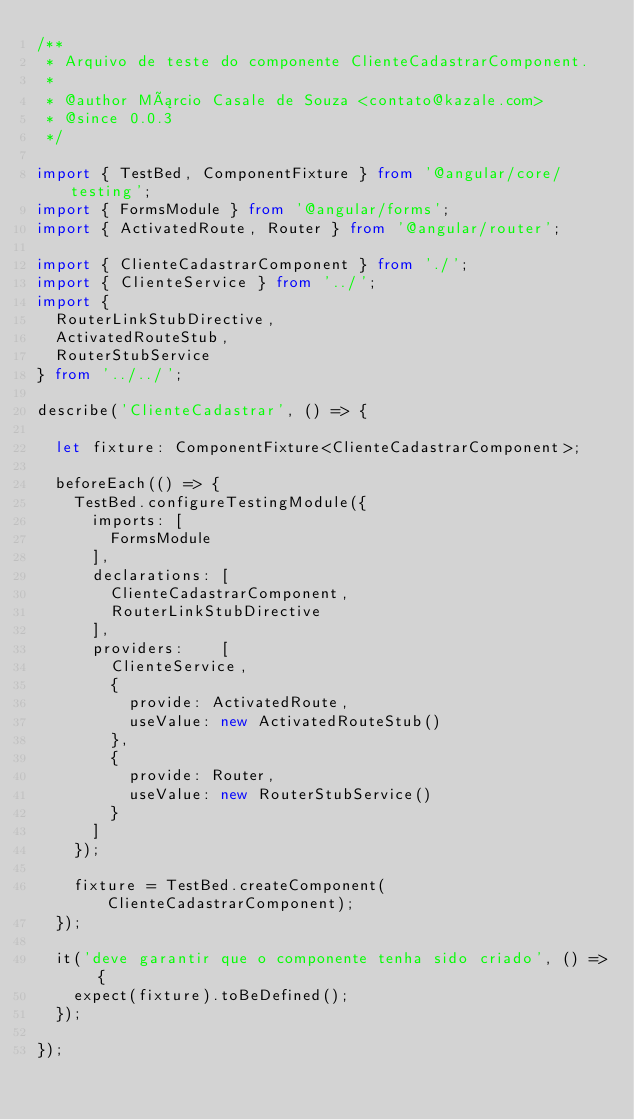Convert code to text. <code><loc_0><loc_0><loc_500><loc_500><_TypeScript_>/**
 * Arquivo de teste do componente ClienteCadastrarComponent.
 *
 * @author Márcio Casale de Souza <contato@kazale.com>
 * @since 0.0.3
 */

import { TestBed, ComponentFixture } from '@angular/core/testing';
import { FormsModule } from '@angular/forms';
import { ActivatedRoute, Router } from '@angular/router';

import { ClienteCadastrarComponent } from './';
import { ClienteService } from '../';
import { 
	RouterLinkStubDirective,
	ActivatedRouteStub,
	RouterStubService
} from '../../';

describe('ClienteCadastrar', () => {

  let fixture: ComponentFixture<ClienteCadastrarComponent>;

  beforeEach(() => {
    TestBed.configureTestingModule({ 
    	imports: [
    		FormsModule
    	],
    	declarations: [ 
    		ClienteCadastrarComponent,
    		RouterLinkStubDirective
    	],
    	providers:    [
    	  ClienteService,
    	  { 
    	  	provide: ActivatedRoute, 
    	  	useValue: new ActivatedRouteStub() 
    	  },
    	  {
    	  	provide: Router,
    	  	useValue: new RouterStubService()
    	  }
    	]
    });

    fixture = TestBed.createComponent(ClienteCadastrarComponent);
  });

  it('deve garantir que o componente tenha sido criado', () => {
    expect(fixture).toBeDefined();
  });
  
});
</code> 